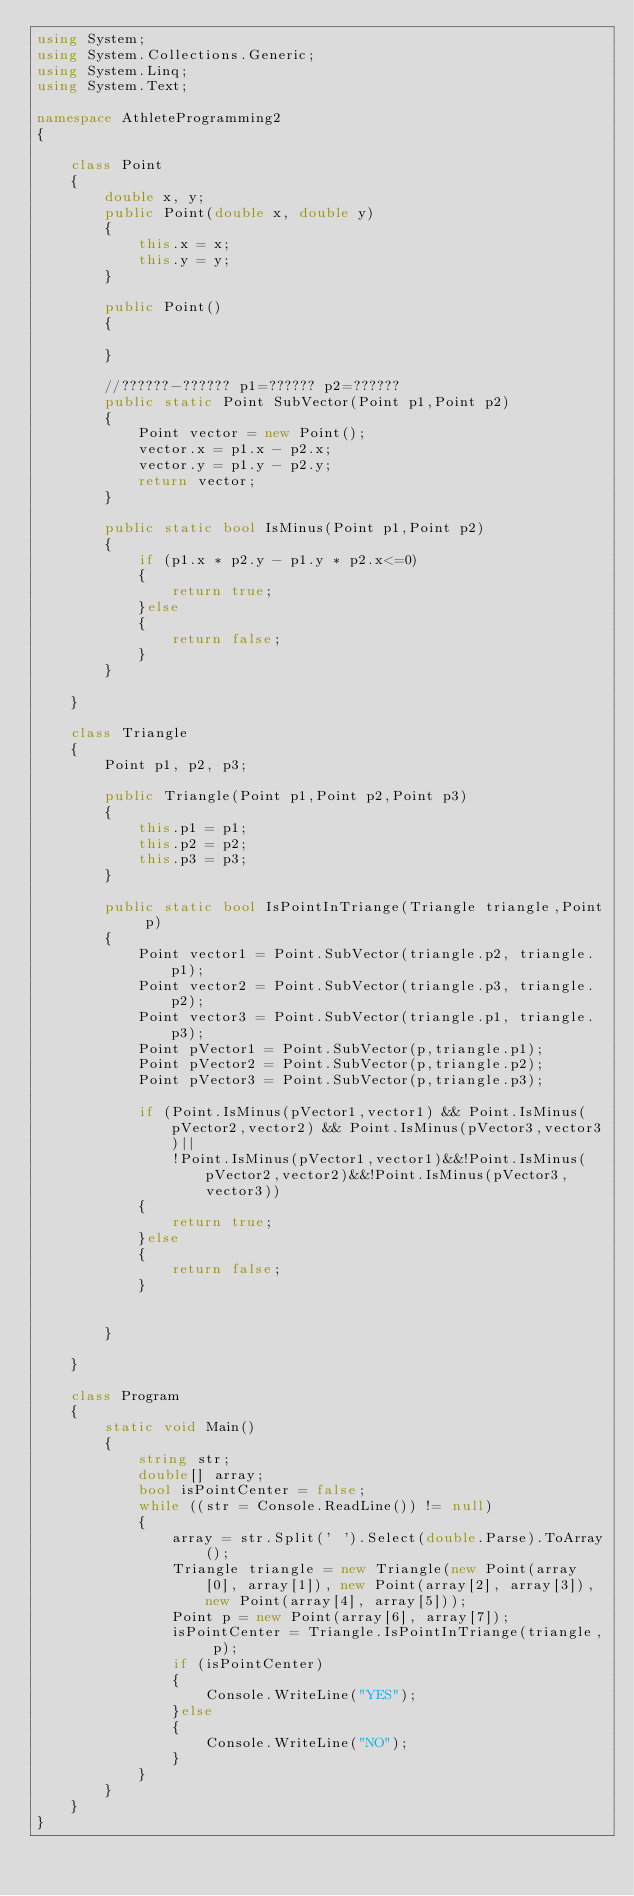<code> <loc_0><loc_0><loc_500><loc_500><_C#_>using System;
using System.Collections.Generic;
using System.Linq;
using System.Text;

namespace AthleteProgramming2
{

    class Point
    {
        double x, y;
        public Point(double x, double y)
        {
            this.x = x;
            this.y = y;
        }

        public Point()
        {

        }

        //??????-?????? p1=?????? p2=??????
        public static Point SubVector(Point p1,Point p2)
        {
            Point vector = new Point();
            vector.x = p1.x - p2.x;
            vector.y = p1.y - p2.y;
            return vector;
        }

        public static bool IsMinus(Point p1,Point p2)
        {
            if (p1.x * p2.y - p1.y * p2.x<=0)
            {
                return true;
            }else
            {
                return false;
            }
        }

    }

    class Triangle
    {
        Point p1, p2, p3;
        
        public Triangle(Point p1,Point p2,Point p3)
        {
            this.p1 = p1;
            this.p2 = p2;
            this.p3 = p3;
        }

        public static bool IsPointInTriange(Triangle triangle,Point p)
        {
            Point vector1 = Point.SubVector(triangle.p2, triangle.p1);
            Point vector2 = Point.SubVector(triangle.p3, triangle.p2);
            Point vector3 = Point.SubVector(triangle.p1, triangle.p3);
            Point pVector1 = Point.SubVector(p,triangle.p1);
            Point pVector2 = Point.SubVector(p,triangle.p2);
            Point pVector3 = Point.SubVector(p,triangle.p3);

            if (Point.IsMinus(pVector1,vector1) && Point.IsMinus(pVector2,vector2) && Point.IsMinus(pVector3,vector3)||
                !Point.IsMinus(pVector1,vector1)&&!Point.IsMinus(pVector2,vector2)&&!Point.IsMinus(pVector3,vector3))
            {
                return true;
            }else
            {
                return false;
            }


        }

    }

    class Program
    {
        static void Main()
        {
            string str;
            double[] array;
            bool isPointCenter = false;
            while ((str = Console.ReadLine()) != null)
            {
                array = str.Split(' ').Select(double.Parse).ToArray();
                Triangle triangle = new Triangle(new Point(array[0], array[1]), new Point(array[2], array[3]), new Point(array[4], array[5]));
                Point p = new Point(array[6], array[7]);
                isPointCenter = Triangle.IsPointInTriange(triangle, p);
                if (isPointCenter)
                {
                    Console.WriteLine("YES");
                }else
                {
                    Console.WriteLine("NO");
                }
            }
        }
    }
}</code> 